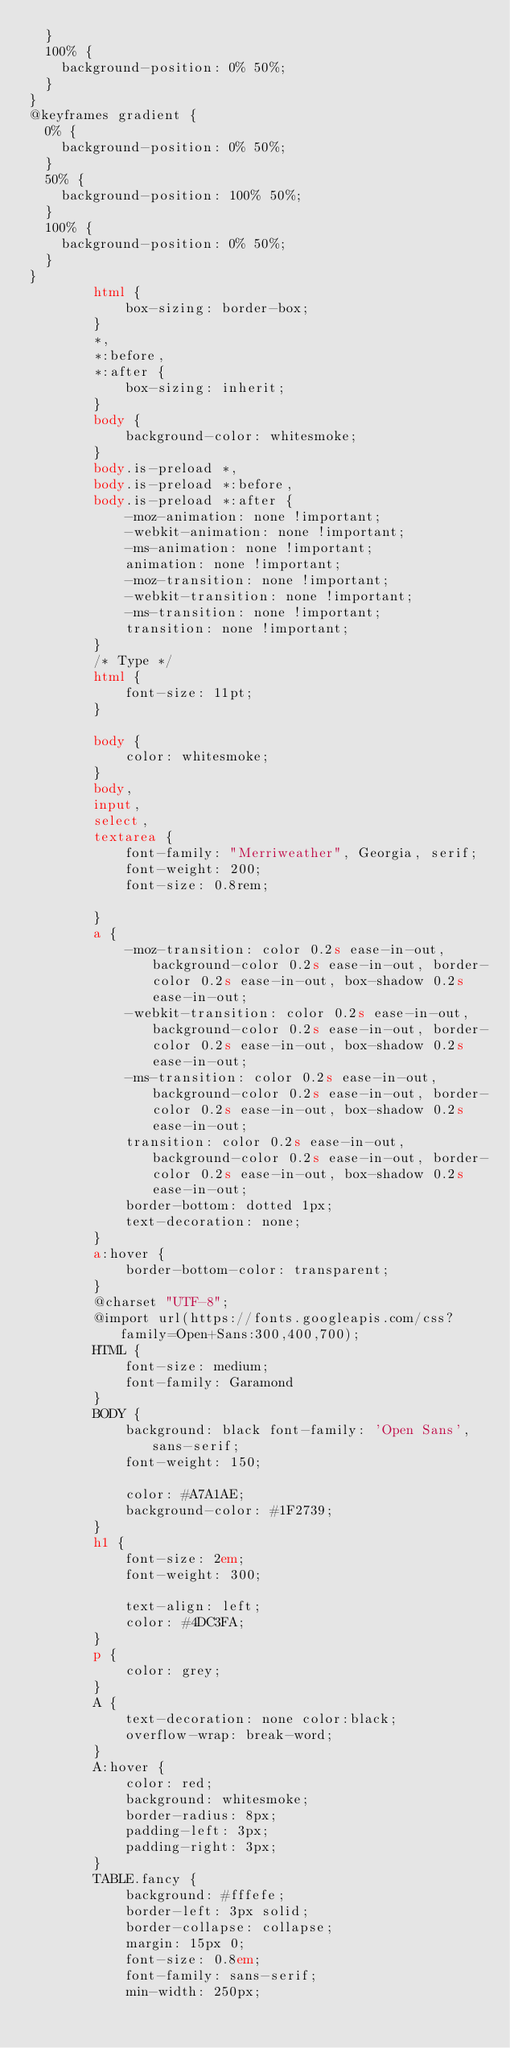<code> <loc_0><loc_0><loc_500><loc_500><_HTML_>  }
  100% {
    background-position: 0% 50%;
  }
}
@keyframes gradient {
  0% {
    background-position: 0% 50%;
  }
  50% {
    background-position: 100% 50%;
  }
  100% {
    background-position: 0% 50%;
  }
}
        html {
            box-sizing: border-box;
        }
        *,
        *:before,
        *:after {
            box-sizing: inherit;
        }
        body {
            background-color: whitesmoke;
        }
        body.is-preload *,
        body.is-preload *:before,
        body.is-preload *:after {
            -moz-animation: none !important;
            -webkit-animation: none !important;
            -ms-animation: none !important;
            animation: none !important;
            -moz-transition: none !important;
            -webkit-transition: none !important;
            -ms-transition: none !important;
            transition: none !important;
        }
        /* Type */
        html {
            font-size: 11pt;
        }
       
        body {
            color: whitesmoke;
        }
        body,
        input,
        select,
        textarea {
            font-family: "Merriweather", Georgia, serif;
            font-weight: 200;
            font-size: 0.8rem;
          
        }
        a {
            -moz-transition: color 0.2s ease-in-out, background-color 0.2s ease-in-out, border-color 0.2s ease-in-out, box-shadow 0.2s ease-in-out;
            -webkit-transition: color 0.2s ease-in-out, background-color 0.2s ease-in-out, border-color 0.2s ease-in-out, box-shadow 0.2s ease-in-out;
            -ms-transition: color 0.2s ease-in-out, background-color 0.2s ease-in-out, border-color 0.2s ease-in-out, box-shadow 0.2s ease-in-out;
            transition: color 0.2s ease-in-out, background-color 0.2s ease-in-out, border-color 0.2s ease-in-out, box-shadow 0.2s ease-in-out;
            border-bottom: dotted 1px;
            text-decoration: none;
        }
        a:hover {
            border-bottom-color: transparent;
        }
        @charset "UTF-8";
        @import url(https://fonts.googleapis.com/css?family=Open+Sans:300,400,700);
        HTML {
            font-size: medium;
            font-family: Garamond
        }
        BODY {
            background: black font-family: 'Open Sans', sans-serif;
            font-weight: 150;
         
            color: #A7A1AE;
            background-color: #1F2739;
        }
        h1 {
            font-size: 2em;
            font-weight: 300;
         
            text-align: left;
            color: #4DC3FA;
        }
        p {
            color: grey;
        }
        A {
            text-decoration: none color:black;
            overflow-wrap: break-word;
        }
        A:hover {
            color: red;
            background: whitesmoke;
            border-radius: 8px;
            padding-left: 3px;
            padding-right: 3px;
        }
        TABLE.fancy {
            background: #fffefe;
            border-left: 3px solid;
            border-collapse: collapse;
            margin: 15px 0;
            font-size: 0.8em;
            font-family: sans-serif;
            min-width: 250px;</code> 